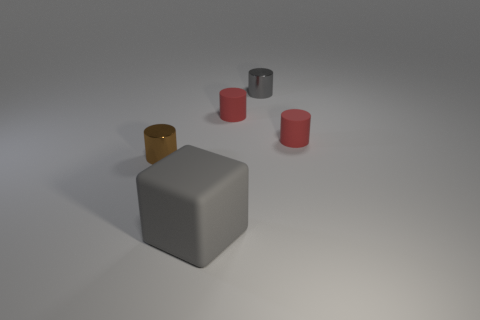Is the material of the gray object that is behind the gray matte block the same as the large gray block?
Your answer should be very brief. No. The metallic thing that is the same color as the large block is what size?
Make the answer very short. Small. What number of blue matte balls are the same size as the brown shiny thing?
Provide a short and direct response. 0. Is the number of large rubber cubes right of the small gray cylinder the same as the number of big gray matte cubes?
Provide a short and direct response. No. How many objects are both to the right of the brown metal thing and behind the big thing?
Offer a terse response. 3. There is another cylinder that is the same material as the gray cylinder; what size is it?
Provide a succinct answer. Small. What number of small red things are the same shape as the small gray shiny thing?
Provide a succinct answer. 2. Are there more big gray matte blocks behind the small gray thing than large cyan shiny objects?
Provide a succinct answer. No. What is the shape of the tiny object that is on the left side of the gray shiny object and right of the big gray matte block?
Keep it short and to the point. Cylinder. Do the brown shiny cylinder and the gray matte object have the same size?
Offer a very short reply. No. 